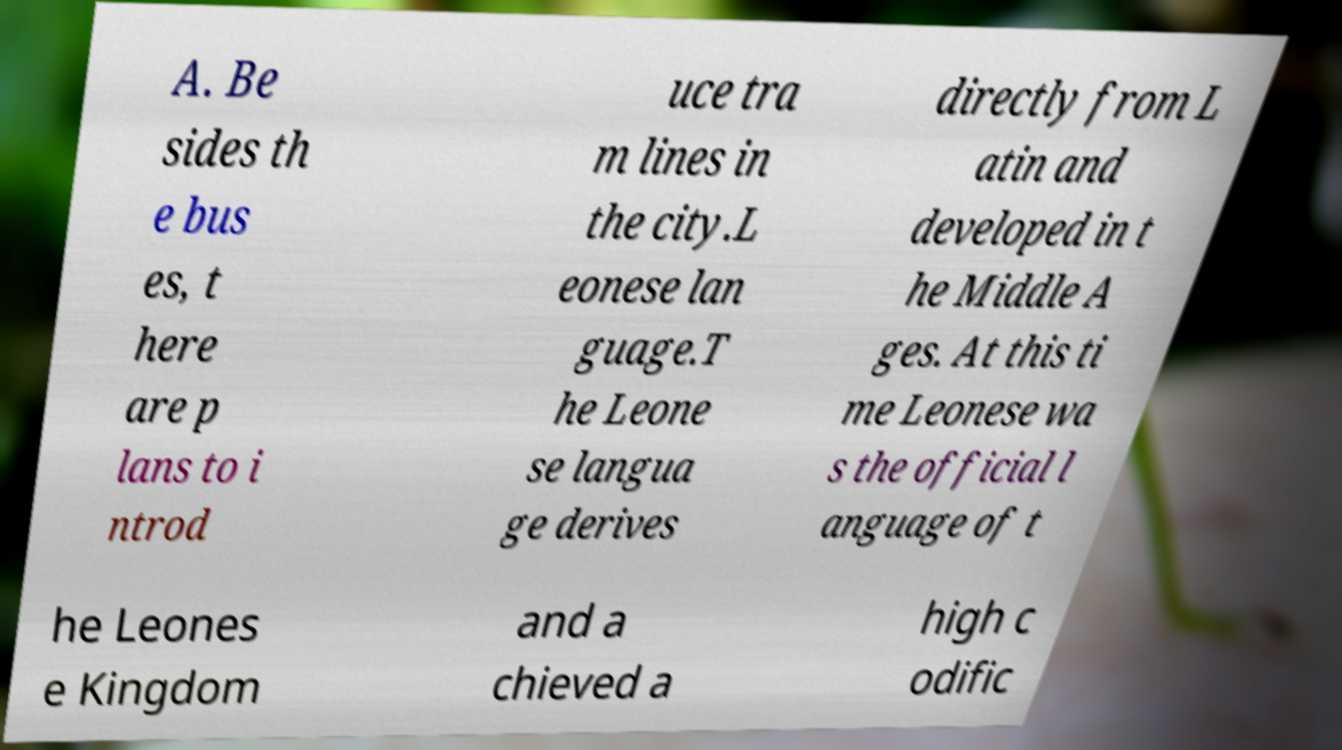Can you read and provide the text displayed in the image?This photo seems to have some interesting text. Can you extract and type it out for me? A. Be sides th e bus es, t here are p lans to i ntrod uce tra m lines in the city.L eonese lan guage.T he Leone se langua ge derives directly from L atin and developed in t he Middle A ges. At this ti me Leonese wa s the official l anguage of t he Leones e Kingdom and a chieved a high c odific 